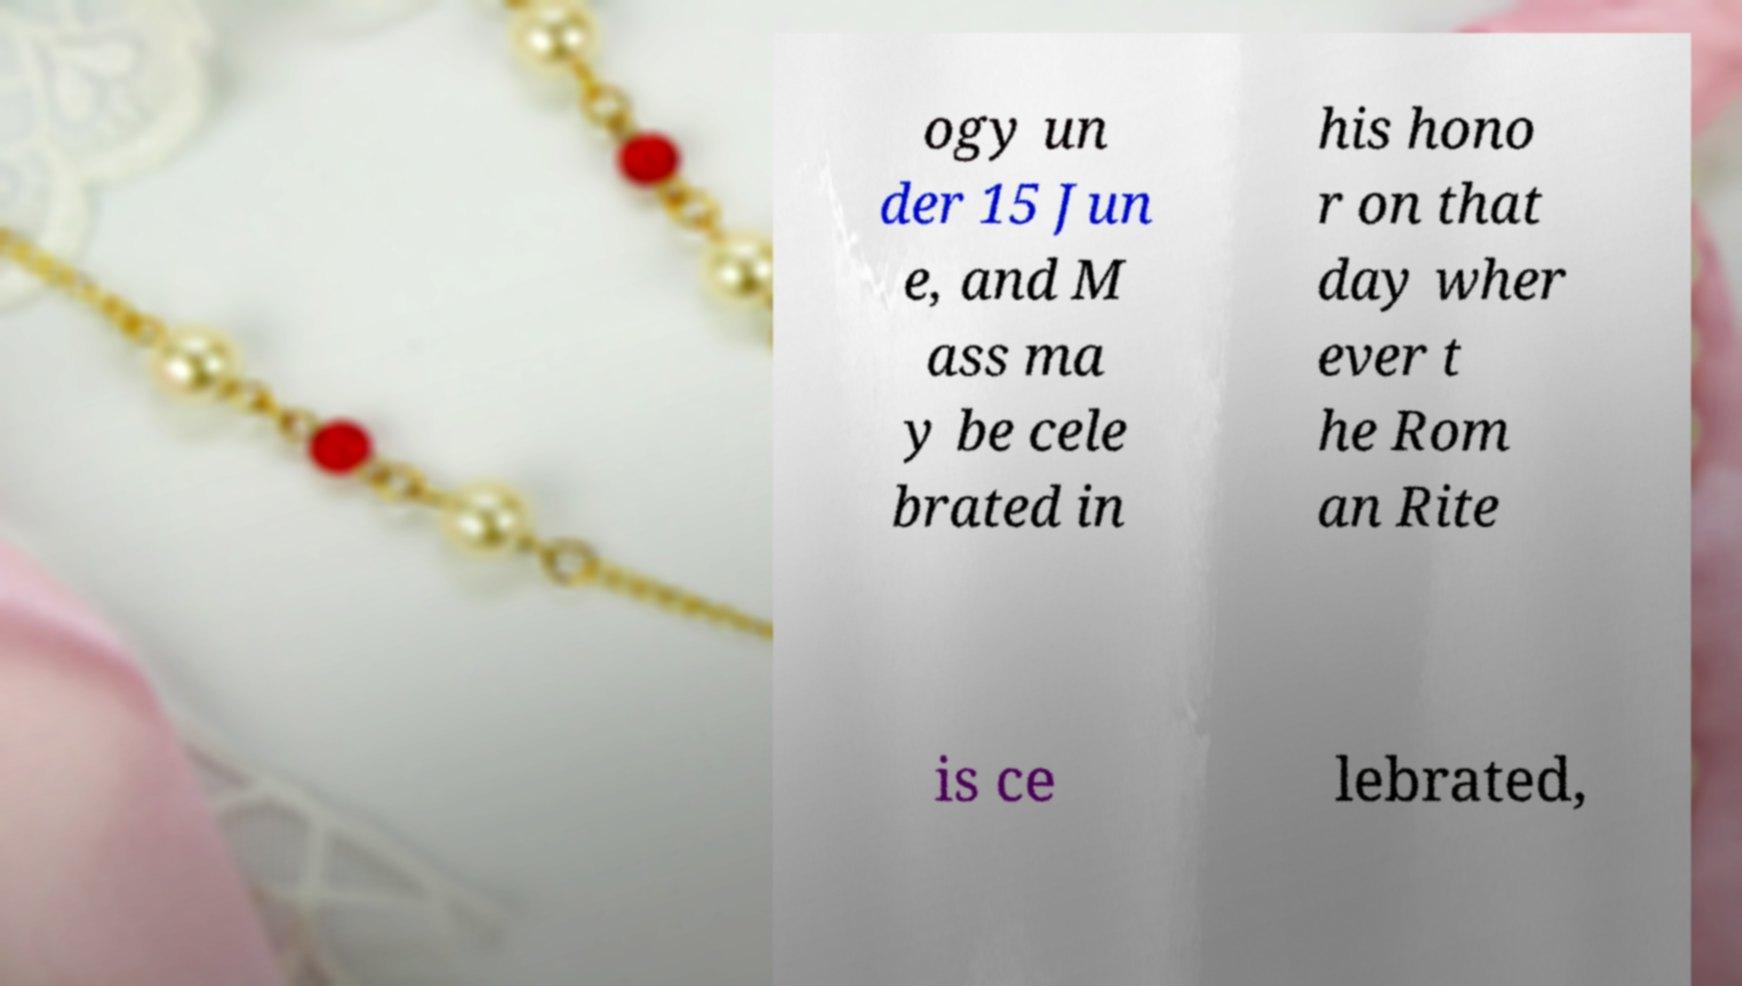Could you assist in decoding the text presented in this image and type it out clearly? ogy un der 15 Jun e, and M ass ma y be cele brated in his hono r on that day wher ever t he Rom an Rite is ce lebrated, 